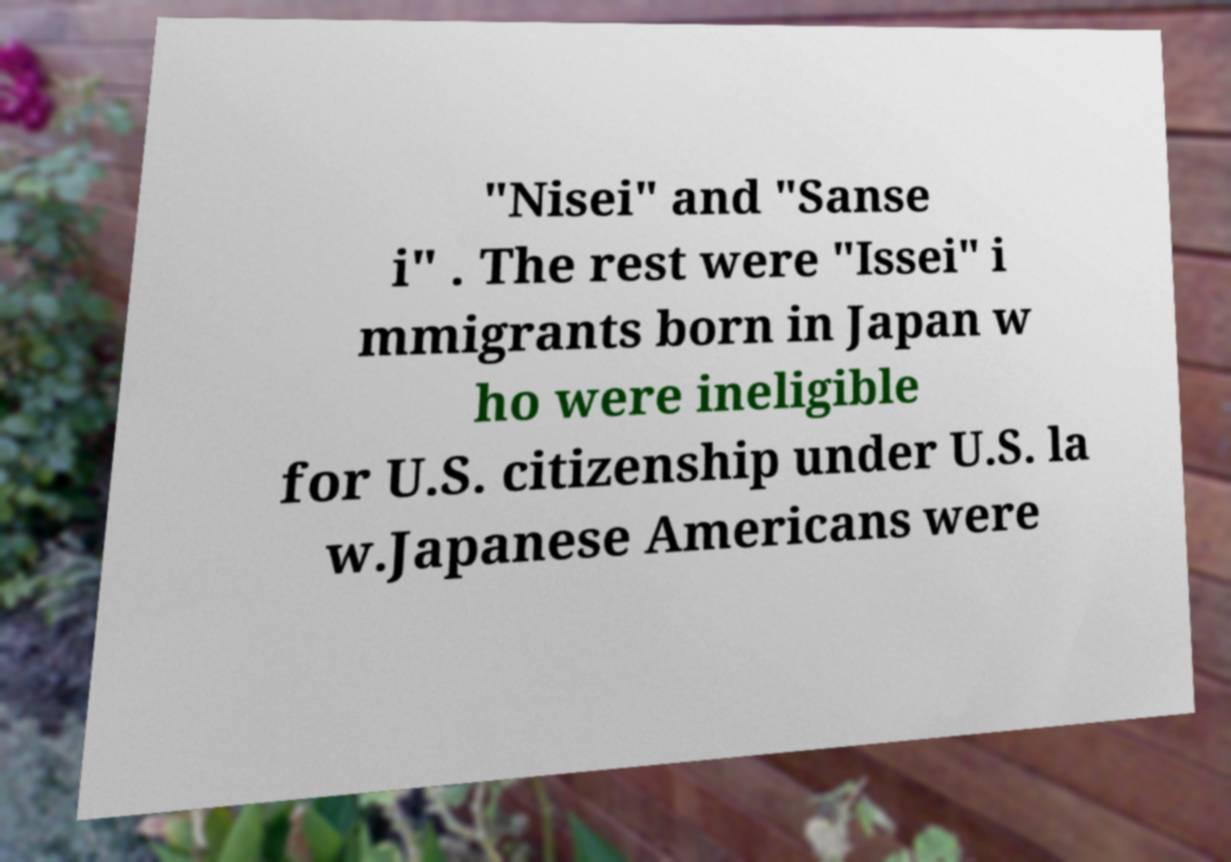I need the written content from this picture converted into text. Can you do that? "Nisei" and "Sanse i" . The rest were "Issei" i mmigrants born in Japan w ho were ineligible for U.S. citizenship under U.S. la w.Japanese Americans were 